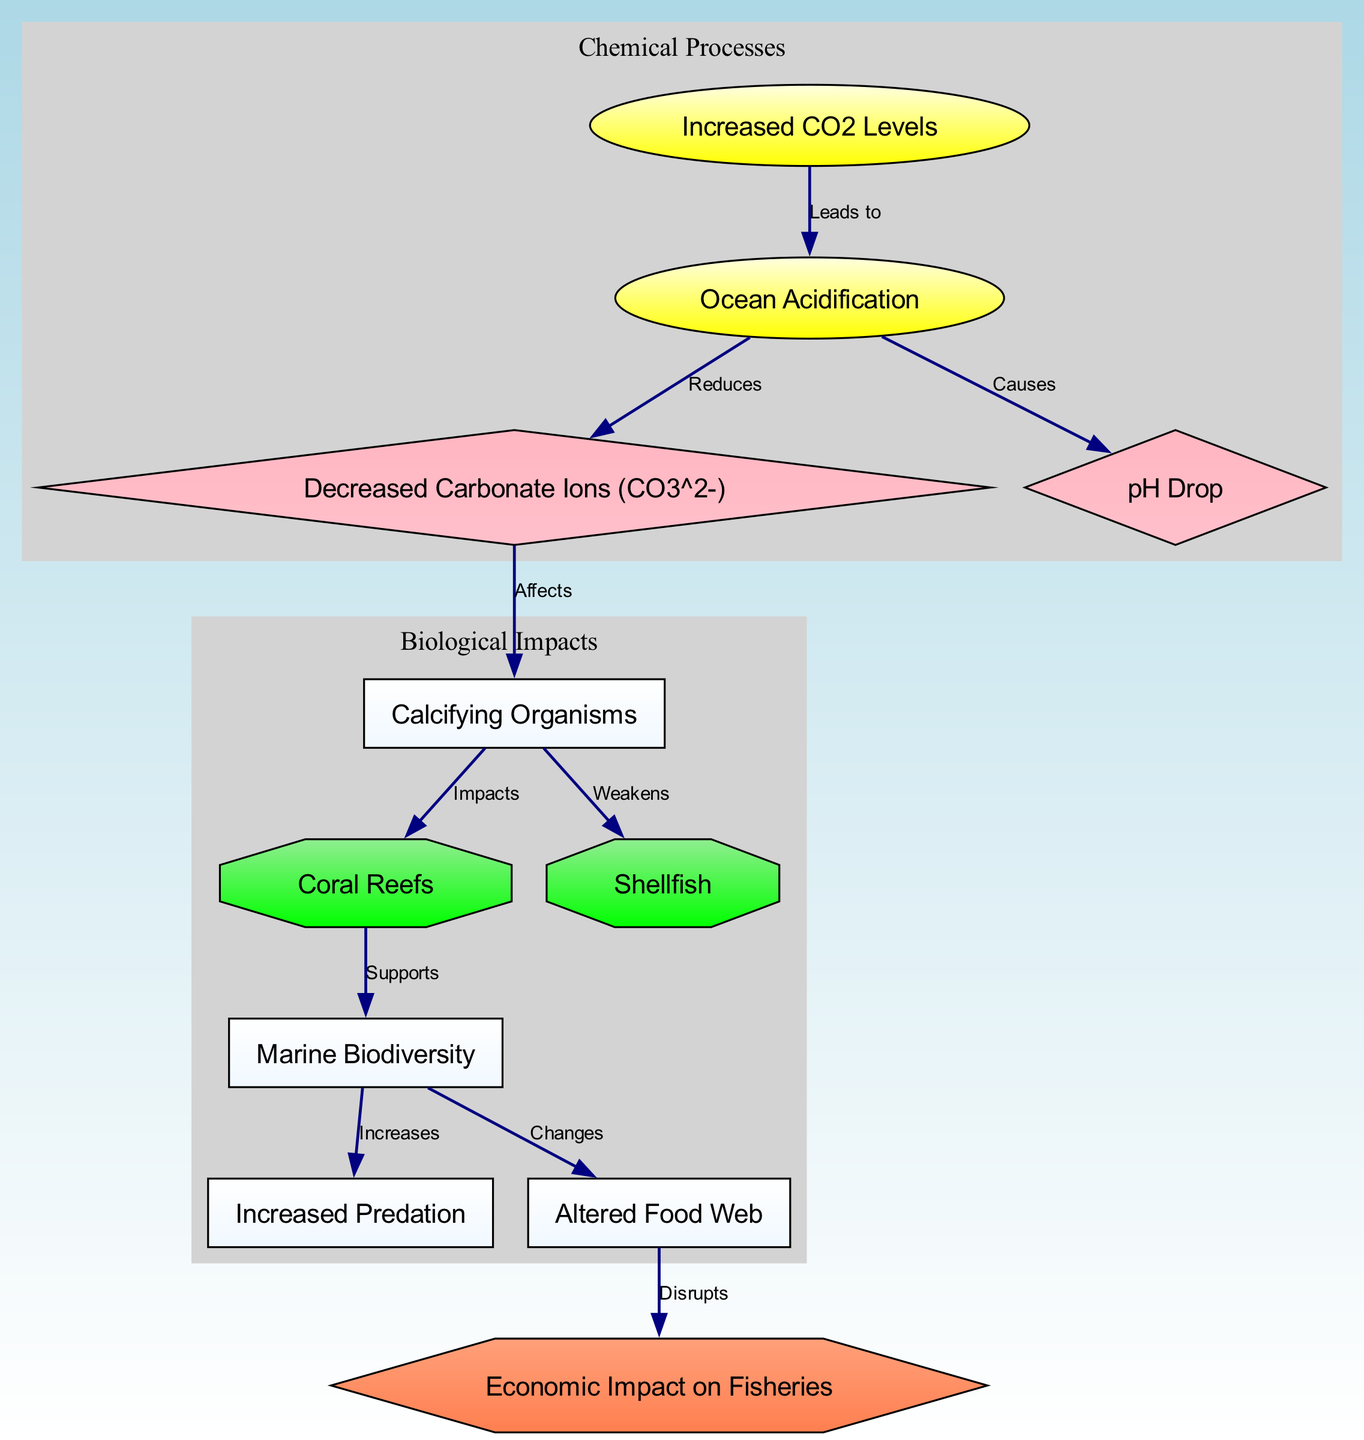What causes ocean acidification? According to the diagram, ocean acidification is caused by increased CO2 levels. You can follow the edge from the node "increased_co2" to the node "ocean_acidification" which indicates this relationship.
Answer: Increased CO2 Levels How does ocean acidification affect carbonate ions? The diagram shows that ocean acidification reduces carbonate ions (CO3^2-). This is represented by the edge from "ocean_acidification" to "carbonate_ions".
Answer: Reduces Which organisms are primarily impacted by the reduction of carbonate ions? The diagram reveals that calcifying organisms are affected by the decreased carbonate ions, as indicated by the edge from "carbonate_ions" to "calcifying_organisms".
Answer: Calcifying Organisms What is the relationship between coral reefs and marine biodiversity? According to the diagram, coral reefs support marine biodiversity. The relationship is indicated by the edge leading from "coral_reefs" to "marine_biodiversity".
Answer: Supports What is the economic impact related to altered food webs? The diagram illustrates that altered food webs disrupt fisheries, with the edge leading from "food_web" to "fisheries". This connection indicates the economic impact.
Answer: Disrupts How many nodes are labeled with an octagon shape? By counting the unique octagon-shaped nodes in the diagram, which are "coral_reefs" and "shellfish," we see there are two. This can be easily identified in the node shapes.
Answer: 2 What increases due to changes in marine biodiversity? The diagram indicates that increased predation occurs due to changes in marine biodiversity. The edge from "marine_biodiversity" to "predation" shows this connection explicitly.
Answer: Increases What major effect does ocean acidification have on shellfish? The relationship depicted shows that shellfish are weakened due to ocean acidification, as indicated by the edge from "calcifying_organisms" to "shellfish".
Answer: Weakens What are the two clusters represented in the diagram? The diagram contains two clusters: one for chemical processes and another for biological impacts, as can be seen from the subgraph labels encapsulating related nodes.
Answer: Chemical Processes and Biological Impacts 